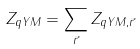<formula> <loc_0><loc_0><loc_500><loc_500>Z _ { q Y M } = \sum _ { \vec { r } } Z _ { q Y M , \vec { r } }</formula> 